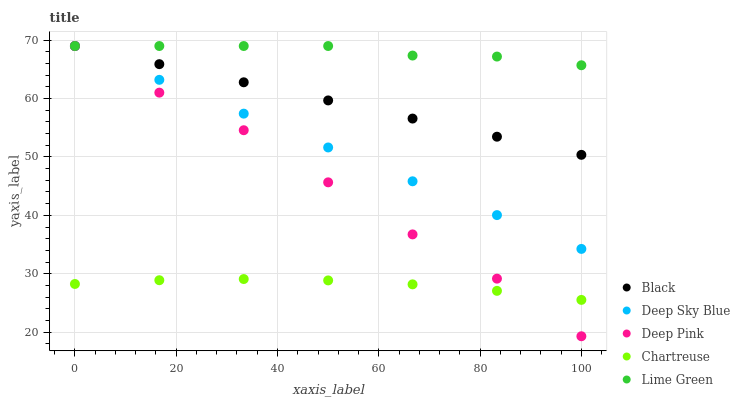Does Chartreuse have the minimum area under the curve?
Answer yes or no. Yes. Does Lime Green have the maximum area under the curve?
Answer yes or no. Yes. Does Deep Pink have the minimum area under the curve?
Answer yes or no. No. Does Deep Pink have the maximum area under the curve?
Answer yes or no. No. Is Black the smoothest?
Answer yes or no. Yes. Is Deep Pink the roughest?
Answer yes or no. Yes. Is Chartreuse the smoothest?
Answer yes or no. No. Is Chartreuse the roughest?
Answer yes or no. No. Does Deep Pink have the lowest value?
Answer yes or no. Yes. Does Chartreuse have the lowest value?
Answer yes or no. No. Does Deep Sky Blue have the highest value?
Answer yes or no. Yes. Does Chartreuse have the highest value?
Answer yes or no. No. Is Chartreuse less than Black?
Answer yes or no. Yes. Is Deep Sky Blue greater than Chartreuse?
Answer yes or no. Yes. Does Lime Green intersect Deep Pink?
Answer yes or no. Yes. Is Lime Green less than Deep Pink?
Answer yes or no. No. Is Lime Green greater than Deep Pink?
Answer yes or no. No. Does Chartreuse intersect Black?
Answer yes or no. No. 